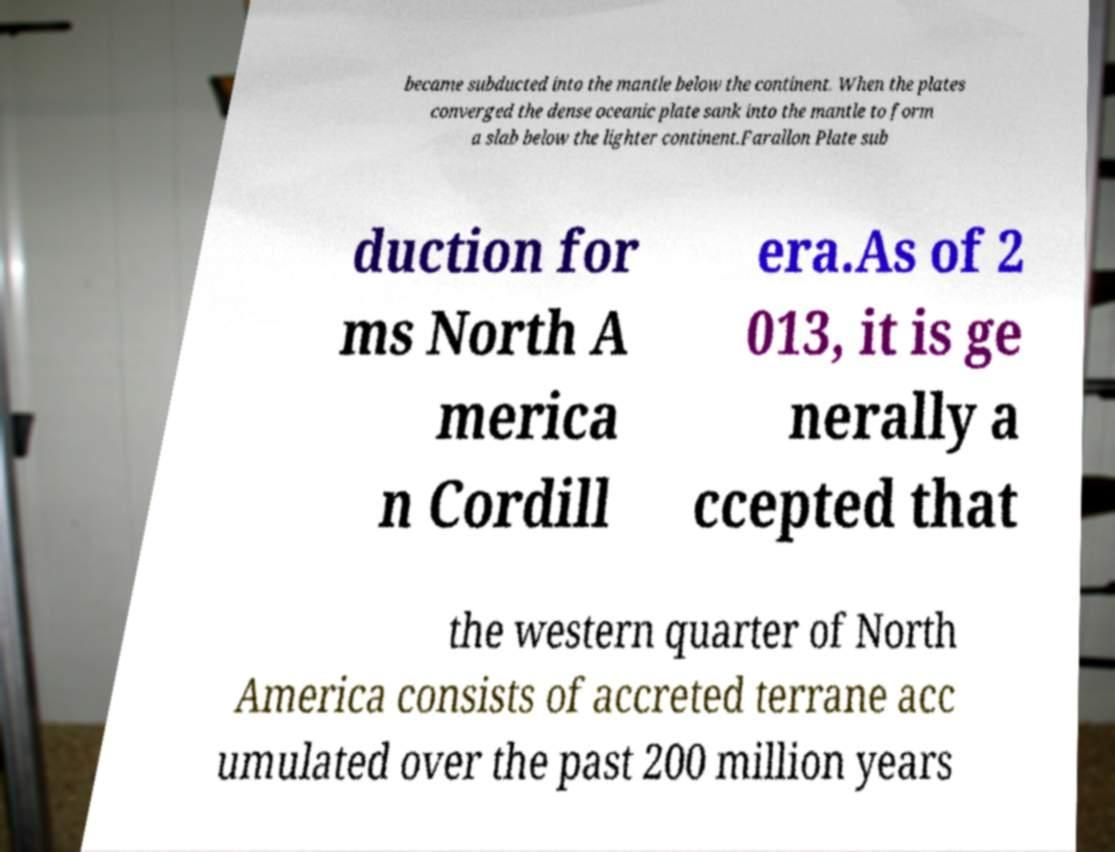There's text embedded in this image that I need extracted. Can you transcribe it verbatim? became subducted into the mantle below the continent. When the plates converged the dense oceanic plate sank into the mantle to form a slab below the lighter continent.Farallon Plate sub duction for ms North A merica n Cordill era.As of 2 013, it is ge nerally a ccepted that the western quarter of North America consists of accreted terrane acc umulated over the past 200 million years 